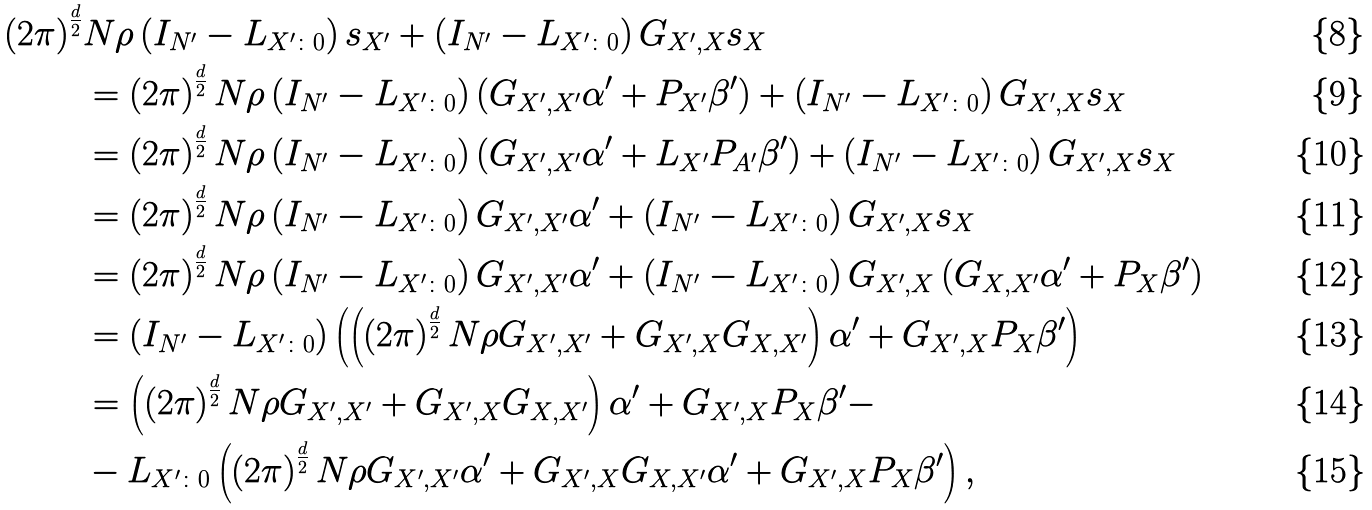<formula> <loc_0><loc_0><loc_500><loc_500>\left ( 2 \pi \right ) ^ { \frac { d } { 2 } } & N \rho \left ( I _ { N ^ { \prime } } - L _ { X ^ { \prime } \colon 0 } \right ) s _ { X ^ { \prime } } + \left ( I _ { N ^ { \prime } } - L _ { X ^ { \prime } \colon 0 } \right ) G _ { X ^ { \prime } , X } s _ { X } \\ & = \left ( 2 \pi \right ) ^ { \frac { d } { 2 } } N \rho \left ( I _ { N ^ { \prime } } - L _ { X ^ { \prime } \colon 0 } \right ) \left ( G _ { X ^ { \prime } , X ^ { \prime } } \alpha ^ { \prime } + P _ { X ^ { \prime } } \beta ^ { \prime } \right ) + \left ( I _ { N ^ { \prime } } - L _ { X ^ { \prime } \colon 0 } \right ) G _ { X ^ { \prime } , X } s _ { X } \\ & = \left ( 2 \pi \right ) ^ { \frac { d } { 2 } } N \rho \left ( I _ { N ^ { \prime } } - L _ { X ^ { \prime } \colon 0 } \right ) \left ( G _ { X ^ { \prime } , X ^ { \prime } } \alpha ^ { \prime } + L _ { X ^ { \prime } } P _ { A ^ { \prime } } \beta ^ { \prime } \right ) + \left ( I _ { N ^ { \prime } } - L _ { X ^ { \prime } \colon 0 } \right ) G _ { X ^ { \prime } , X } s _ { X } \\ & = \left ( 2 \pi \right ) ^ { \frac { d } { 2 } } N \rho \left ( I _ { N ^ { \prime } } - L _ { X ^ { \prime } \colon 0 } \right ) G _ { X ^ { \prime } , X ^ { \prime } } \alpha ^ { \prime } + \left ( I _ { N ^ { \prime } } - L _ { X ^ { \prime } \colon 0 } \right ) G _ { X ^ { \prime } , X } s _ { X } \\ & = \left ( 2 \pi \right ) ^ { \frac { d } { 2 } } N \rho \left ( I _ { N ^ { \prime } } - L _ { X ^ { \prime } \colon 0 } \right ) G _ { X ^ { \prime } , X ^ { \prime } } \alpha ^ { \prime } + \left ( I _ { N ^ { \prime } } - L _ { X ^ { \prime } \colon 0 } \right ) G _ { X ^ { \prime } , X } \left ( G _ { X , X ^ { \prime } } \alpha ^ { \prime } + P _ { X } \beta ^ { \prime } \right ) \\ & = \left ( I _ { N ^ { \prime } } - L _ { X ^ { \prime } \colon 0 } \right ) \left ( \left ( \left ( 2 \pi \right ) ^ { \frac { d } { 2 } } N \rho G _ { X ^ { \prime } , X ^ { \prime } } + G _ { X ^ { \prime } , X } G _ { X , X ^ { \prime } } \right ) \alpha ^ { \prime } + G _ { X ^ { \prime } , X } P _ { X } \beta ^ { \prime } \right ) \\ & = \left ( \left ( 2 \pi \right ) ^ { \frac { d } { 2 } } N \rho G _ { X ^ { \prime } , X ^ { \prime } } + G _ { X ^ { \prime } , X } G _ { X , X ^ { \prime } } \right ) \alpha ^ { \prime } + G _ { X ^ { \prime } , X } P _ { X } \beta ^ { \prime } - \\ & - L _ { X ^ { \prime } \colon 0 } \left ( \left ( 2 \pi \right ) ^ { \frac { d } { 2 } } N \rho G _ { X ^ { \prime } , X ^ { \prime } } \alpha ^ { \prime } + G _ { X ^ { \prime } , X } G _ { X , X ^ { \prime } } \alpha ^ { \prime } + G _ { X ^ { \prime } , X } P _ { X } \beta ^ { \prime } \right ) ,</formula> 